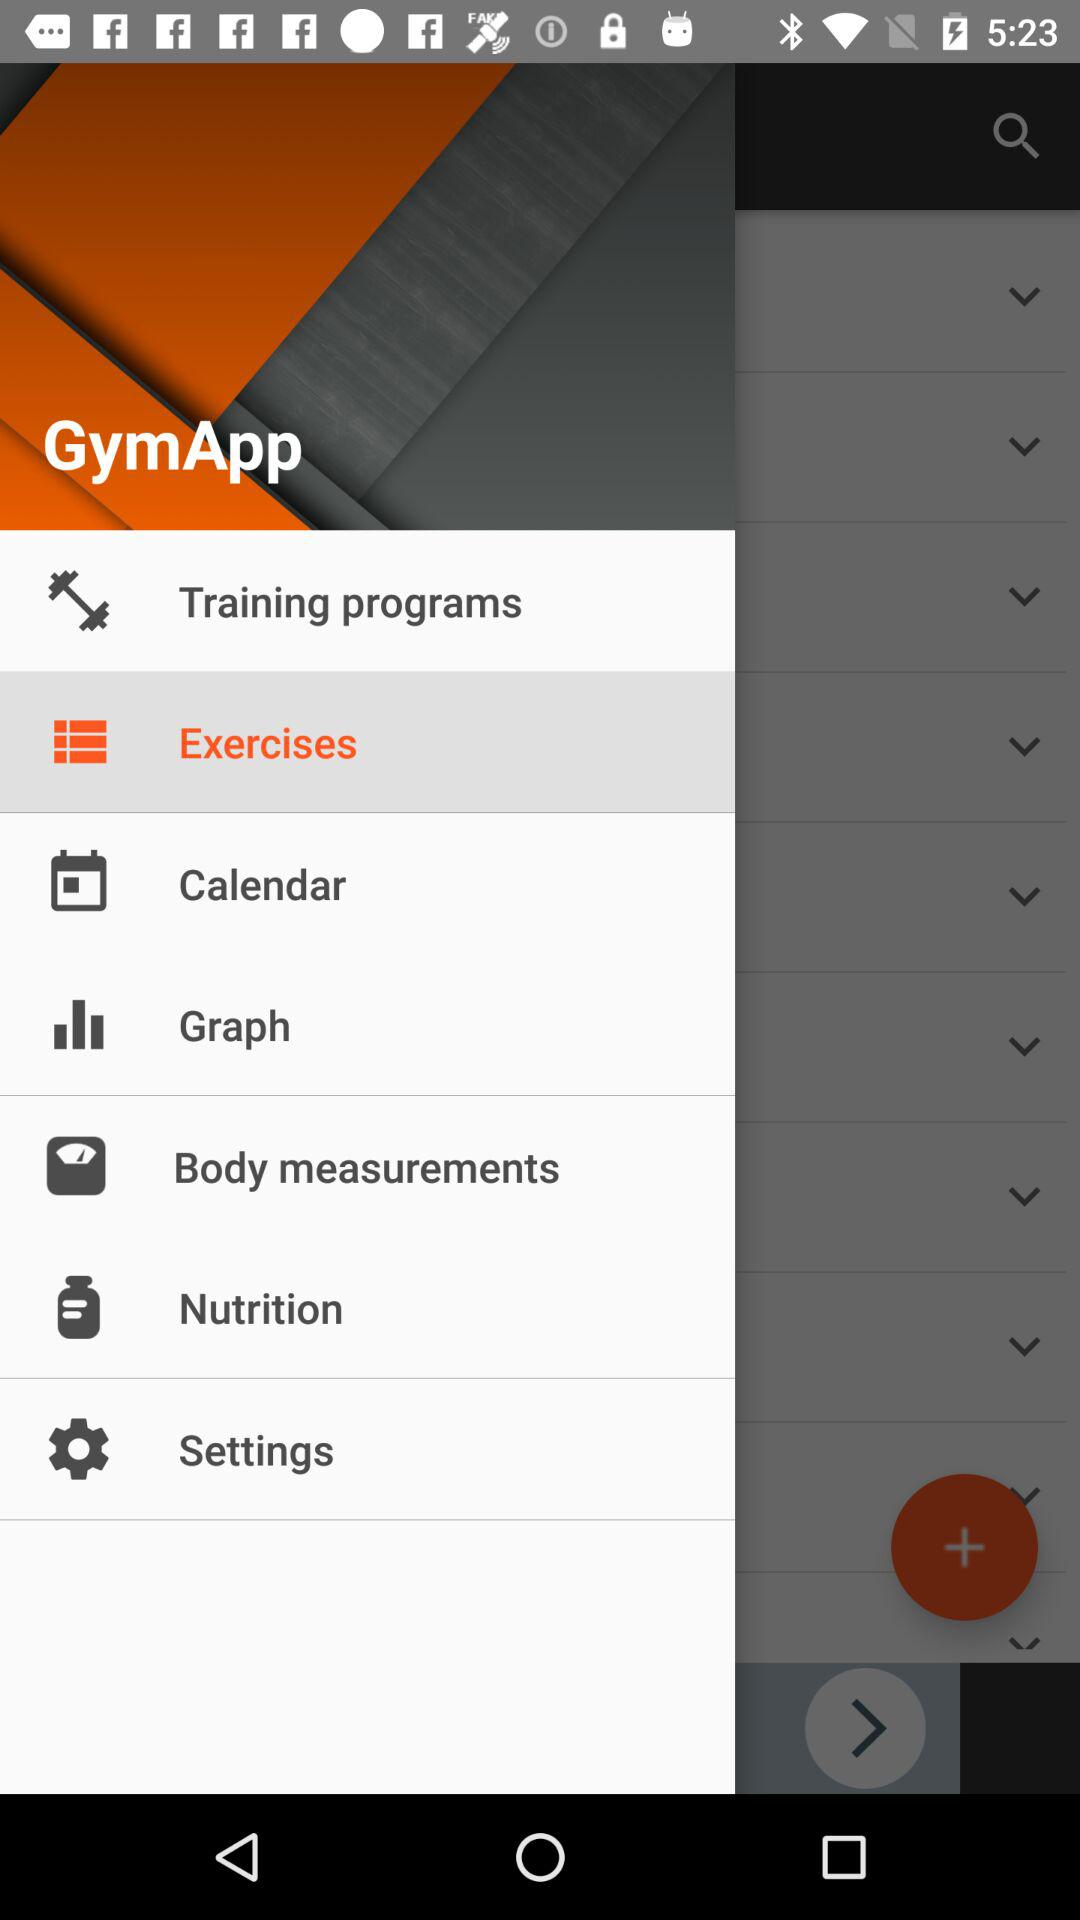Which option is selected? The selected option is "Exercises". 